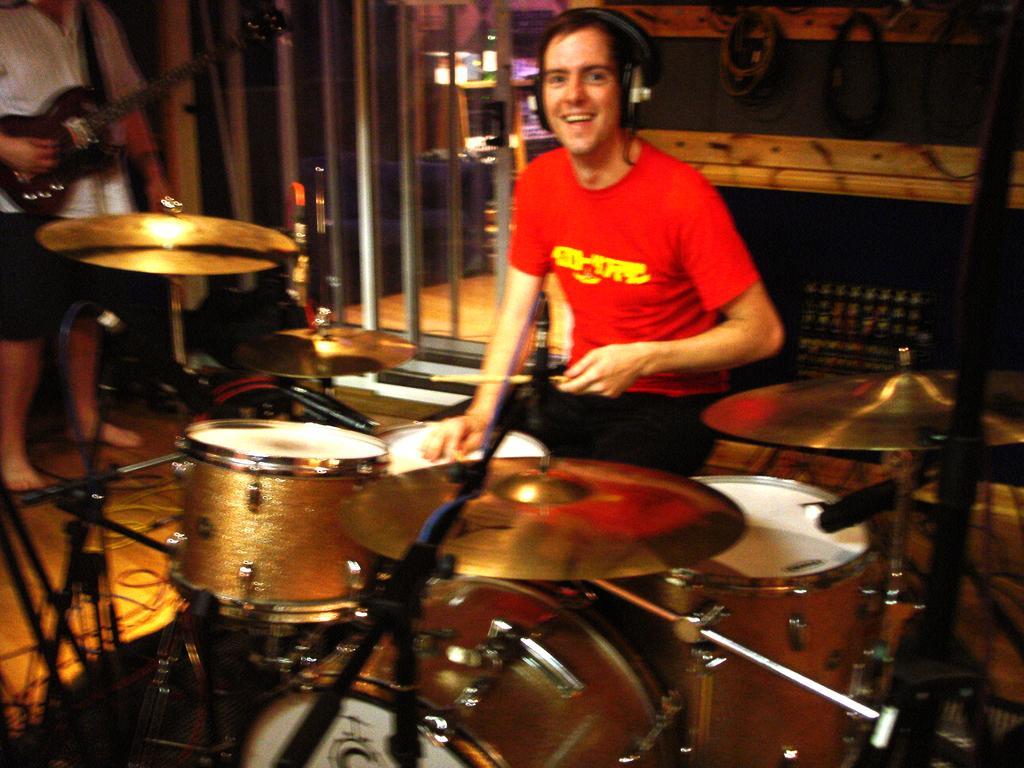In one or two sentences, can you explain what this image depicts? In the center of the picture there is a person playing drums. On the left there is a person playing guitar. In the background there is a room and there are some objects in it. 